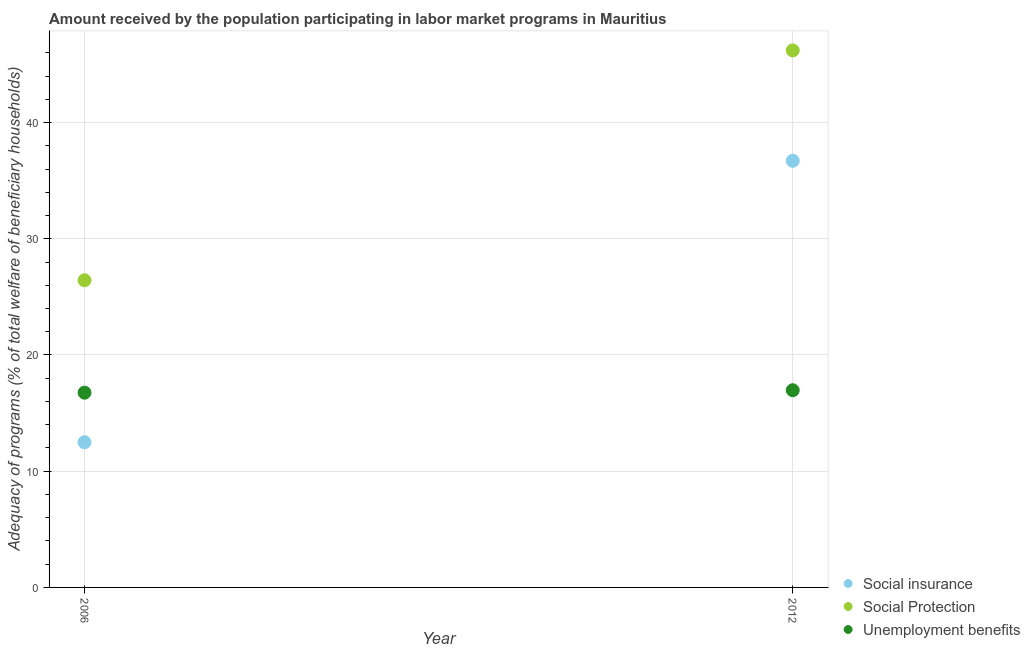What is the amount received by the population participating in social insurance programs in 2012?
Keep it short and to the point. 36.71. Across all years, what is the maximum amount received by the population participating in social insurance programs?
Offer a terse response. 36.71. Across all years, what is the minimum amount received by the population participating in social insurance programs?
Your response must be concise. 12.49. In which year was the amount received by the population participating in social protection programs maximum?
Provide a short and direct response. 2012. In which year was the amount received by the population participating in social protection programs minimum?
Provide a short and direct response. 2006. What is the total amount received by the population participating in social insurance programs in the graph?
Offer a terse response. 49.2. What is the difference between the amount received by the population participating in unemployment benefits programs in 2006 and that in 2012?
Your answer should be compact. -0.21. What is the difference between the amount received by the population participating in social insurance programs in 2006 and the amount received by the population participating in social protection programs in 2012?
Provide a succinct answer. -33.71. What is the average amount received by the population participating in social protection programs per year?
Provide a short and direct response. 36.32. In the year 2006, what is the difference between the amount received by the population participating in unemployment benefits programs and amount received by the population participating in social insurance programs?
Provide a succinct answer. 4.26. In how many years, is the amount received by the population participating in social insurance programs greater than 28 %?
Provide a short and direct response. 1. What is the ratio of the amount received by the population participating in unemployment benefits programs in 2006 to that in 2012?
Provide a short and direct response. 0.99. Is the amount received by the population participating in social insurance programs strictly greater than the amount received by the population participating in social protection programs over the years?
Make the answer very short. No. Is the amount received by the population participating in unemployment benefits programs strictly less than the amount received by the population participating in social protection programs over the years?
Your answer should be compact. Yes. Are the values on the major ticks of Y-axis written in scientific E-notation?
Offer a terse response. No. How are the legend labels stacked?
Provide a succinct answer. Vertical. What is the title of the graph?
Provide a succinct answer. Amount received by the population participating in labor market programs in Mauritius. What is the label or title of the Y-axis?
Keep it short and to the point. Adequacy of programs (% of total welfare of beneficiary households). What is the Adequacy of programs (% of total welfare of beneficiary households) of Social insurance in 2006?
Make the answer very short. 12.49. What is the Adequacy of programs (% of total welfare of beneficiary households) of Social Protection in 2006?
Your answer should be compact. 26.43. What is the Adequacy of programs (% of total welfare of beneficiary households) in Unemployment benefits in 2006?
Make the answer very short. 16.76. What is the Adequacy of programs (% of total welfare of beneficiary households) in Social insurance in 2012?
Provide a short and direct response. 36.71. What is the Adequacy of programs (% of total welfare of beneficiary households) of Social Protection in 2012?
Keep it short and to the point. 46.21. What is the Adequacy of programs (% of total welfare of beneficiary households) in Unemployment benefits in 2012?
Provide a short and direct response. 16.97. Across all years, what is the maximum Adequacy of programs (% of total welfare of beneficiary households) in Social insurance?
Offer a very short reply. 36.71. Across all years, what is the maximum Adequacy of programs (% of total welfare of beneficiary households) of Social Protection?
Your answer should be very brief. 46.21. Across all years, what is the maximum Adequacy of programs (% of total welfare of beneficiary households) in Unemployment benefits?
Give a very brief answer. 16.97. Across all years, what is the minimum Adequacy of programs (% of total welfare of beneficiary households) of Social insurance?
Make the answer very short. 12.49. Across all years, what is the minimum Adequacy of programs (% of total welfare of beneficiary households) in Social Protection?
Ensure brevity in your answer.  26.43. Across all years, what is the minimum Adequacy of programs (% of total welfare of beneficiary households) of Unemployment benefits?
Your response must be concise. 16.76. What is the total Adequacy of programs (% of total welfare of beneficiary households) of Social insurance in the graph?
Your response must be concise. 49.2. What is the total Adequacy of programs (% of total welfare of beneficiary households) of Social Protection in the graph?
Your response must be concise. 72.64. What is the total Adequacy of programs (% of total welfare of beneficiary households) of Unemployment benefits in the graph?
Offer a terse response. 33.73. What is the difference between the Adequacy of programs (% of total welfare of beneficiary households) in Social insurance in 2006 and that in 2012?
Make the answer very short. -24.22. What is the difference between the Adequacy of programs (% of total welfare of beneficiary households) of Social Protection in 2006 and that in 2012?
Your answer should be compact. -19.78. What is the difference between the Adequacy of programs (% of total welfare of beneficiary households) of Unemployment benefits in 2006 and that in 2012?
Provide a short and direct response. -0.21. What is the difference between the Adequacy of programs (% of total welfare of beneficiary households) in Social insurance in 2006 and the Adequacy of programs (% of total welfare of beneficiary households) in Social Protection in 2012?
Keep it short and to the point. -33.71. What is the difference between the Adequacy of programs (% of total welfare of beneficiary households) in Social insurance in 2006 and the Adequacy of programs (% of total welfare of beneficiary households) in Unemployment benefits in 2012?
Provide a succinct answer. -4.47. What is the difference between the Adequacy of programs (% of total welfare of beneficiary households) in Social Protection in 2006 and the Adequacy of programs (% of total welfare of beneficiary households) in Unemployment benefits in 2012?
Provide a succinct answer. 9.46. What is the average Adequacy of programs (% of total welfare of beneficiary households) in Social insurance per year?
Provide a short and direct response. 24.6. What is the average Adequacy of programs (% of total welfare of beneficiary households) in Social Protection per year?
Keep it short and to the point. 36.32. What is the average Adequacy of programs (% of total welfare of beneficiary households) in Unemployment benefits per year?
Your response must be concise. 16.86. In the year 2006, what is the difference between the Adequacy of programs (% of total welfare of beneficiary households) of Social insurance and Adequacy of programs (% of total welfare of beneficiary households) of Social Protection?
Provide a succinct answer. -13.94. In the year 2006, what is the difference between the Adequacy of programs (% of total welfare of beneficiary households) of Social insurance and Adequacy of programs (% of total welfare of beneficiary households) of Unemployment benefits?
Make the answer very short. -4.26. In the year 2006, what is the difference between the Adequacy of programs (% of total welfare of beneficiary households) in Social Protection and Adequacy of programs (% of total welfare of beneficiary households) in Unemployment benefits?
Your answer should be very brief. 9.67. In the year 2012, what is the difference between the Adequacy of programs (% of total welfare of beneficiary households) of Social insurance and Adequacy of programs (% of total welfare of beneficiary households) of Social Protection?
Make the answer very short. -9.5. In the year 2012, what is the difference between the Adequacy of programs (% of total welfare of beneficiary households) in Social insurance and Adequacy of programs (% of total welfare of beneficiary households) in Unemployment benefits?
Keep it short and to the point. 19.74. In the year 2012, what is the difference between the Adequacy of programs (% of total welfare of beneficiary households) in Social Protection and Adequacy of programs (% of total welfare of beneficiary households) in Unemployment benefits?
Make the answer very short. 29.24. What is the ratio of the Adequacy of programs (% of total welfare of beneficiary households) of Social insurance in 2006 to that in 2012?
Your answer should be very brief. 0.34. What is the ratio of the Adequacy of programs (% of total welfare of beneficiary households) of Social Protection in 2006 to that in 2012?
Your response must be concise. 0.57. What is the ratio of the Adequacy of programs (% of total welfare of beneficiary households) in Unemployment benefits in 2006 to that in 2012?
Your answer should be compact. 0.99. What is the difference between the highest and the second highest Adequacy of programs (% of total welfare of beneficiary households) in Social insurance?
Offer a terse response. 24.22. What is the difference between the highest and the second highest Adequacy of programs (% of total welfare of beneficiary households) in Social Protection?
Your answer should be very brief. 19.78. What is the difference between the highest and the second highest Adequacy of programs (% of total welfare of beneficiary households) in Unemployment benefits?
Your answer should be very brief. 0.21. What is the difference between the highest and the lowest Adequacy of programs (% of total welfare of beneficiary households) of Social insurance?
Your response must be concise. 24.22. What is the difference between the highest and the lowest Adequacy of programs (% of total welfare of beneficiary households) of Social Protection?
Offer a terse response. 19.78. What is the difference between the highest and the lowest Adequacy of programs (% of total welfare of beneficiary households) in Unemployment benefits?
Provide a short and direct response. 0.21. 